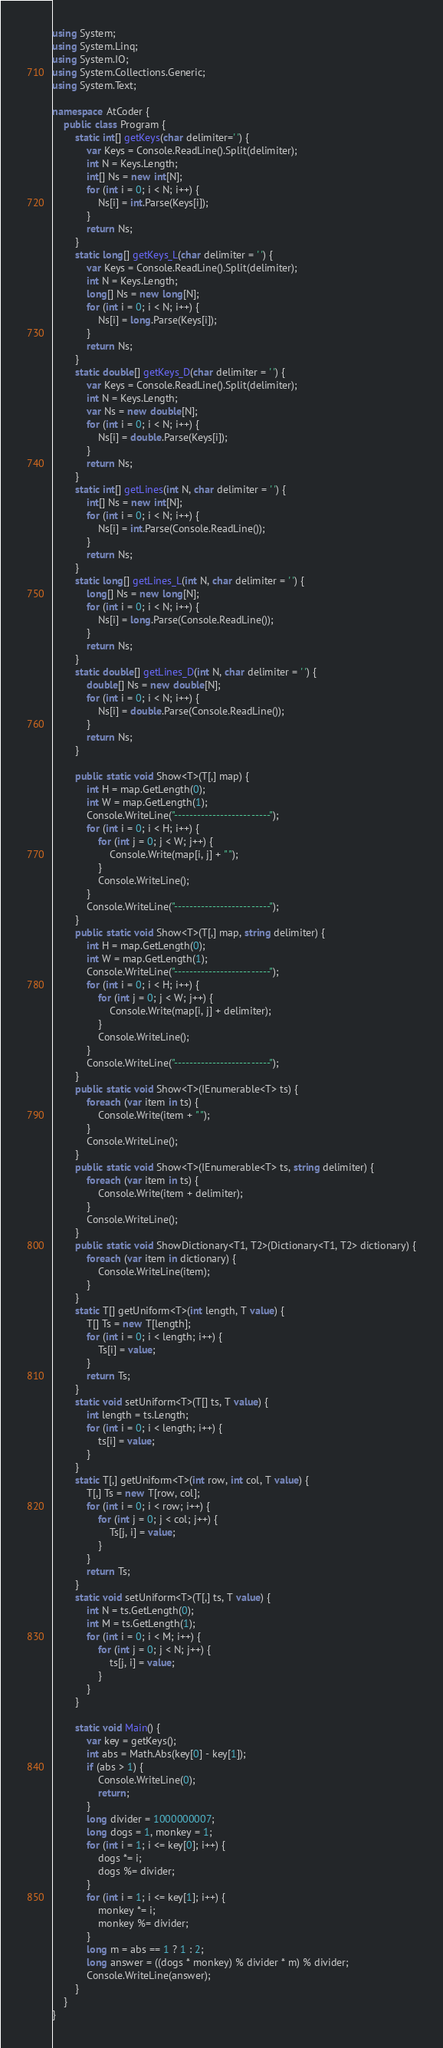<code> <loc_0><loc_0><loc_500><loc_500><_C#_>using System;
using System.Linq;
using System.IO;
using System.Collections.Generic;
using System.Text;

namespace AtCoder {
    public class Program {
        static int[] getKeys(char delimiter=' ') {
            var Keys = Console.ReadLine().Split(delimiter);
            int N = Keys.Length;
            int[] Ns = new int[N];
            for (int i = 0; i < N; i++) {
                Ns[i] = int.Parse(Keys[i]);
            }
            return Ns;
        }
        static long[] getKeys_L(char delimiter = ' ') {
            var Keys = Console.ReadLine().Split(delimiter);
            int N = Keys.Length;
            long[] Ns = new long[N];
            for (int i = 0; i < N; i++) {
                Ns[i] = long.Parse(Keys[i]);
            }
            return Ns;
        }
        static double[] getKeys_D(char delimiter = ' ') {
            var Keys = Console.ReadLine().Split(delimiter);
            int N = Keys.Length;
            var Ns = new double[N];
            for (int i = 0; i < N; i++) {
                Ns[i] = double.Parse(Keys[i]);
            }
            return Ns;
        }
        static int[] getLines(int N, char delimiter = ' ') {
            int[] Ns = new int[N];
            for (int i = 0; i < N; i++) {
                Ns[i] = int.Parse(Console.ReadLine());
            }
            return Ns;
        }
        static long[] getLines_L(int N, char delimiter = ' ') {
            long[] Ns = new long[N];
            for (int i = 0; i < N; i++) {
                Ns[i] = long.Parse(Console.ReadLine());
            }
            return Ns;
        }
        static double[] getLines_D(int N, char delimiter = ' ') {
            double[] Ns = new double[N];
            for (int i = 0; i < N; i++) {
                Ns[i] = double.Parse(Console.ReadLine());
            }
            return Ns;
        }

        public static void Show<T>(T[,] map) {
            int H = map.GetLength(0);
            int W = map.GetLength(1);
            Console.WriteLine("-------------------------");
            for (int i = 0; i < H; i++) {
                for (int j = 0; j < W; j++) {
                    Console.Write(map[i, j] + " ");
                }
                Console.WriteLine();
            }
            Console.WriteLine("-------------------------");
        }
        public static void Show<T>(T[,] map, string delimiter) {
            int H = map.GetLength(0);
            int W = map.GetLength(1);
            Console.WriteLine("-------------------------");
            for (int i = 0; i < H; i++) {
                for (int j = 0; j < W; j++) {
                    Console.Write(map[i, j] + delimiter);
                }
                Console.WriteLine();
            }
            Console.WriteLine("-------------------------");
        }
        public static void Show<T>(IEnumerable<T> ts) {
            foreach (var item in ts) {
                Console.Write(item + " ");
            }
            Console.WriteLine();
        }
        public static void Show<T>(IEnumerable<T> ts, string delimiter) {
            foreach (var item in ts) {
                Console.Write(item + delimiter);
            }
            Console.WriteLine();
        }
        public static void ShowDictionary<T1, T2>(Dictionary<T1, T2> dictionary) {
            foreach (var item in dictionary) {
                Console.WriteLine(item);
            }
        }
        static T[] getUniform<T>(int length, T value) {
            T[] Ts = new T[length];
            for (int i = 0; i < length; i++) {
                Ts[i] = value;
            }
            return Ts;
        }
        static void setUniform<T>(T[] ts, T value) {
            int length = ts.Length;
            for (int i = 0; i < length; i++) {
                ts[i] = value;
            }
        }
        static T[,] getUniform<T>(int row, int col, T value) {
            T[,] Ts = new T[row, col];
            for (int i = 0; i < row; i++) {
                for (int j = 0; j < col; j++) {
                    Ts[j, i] = value;
                }
            }
            return Ts;
        }
        static void setUniform<T>(T[,] ts, T value) {
            int N = ts.GetLength(0);
            int M = ts.GetLength(1);
            for (int i = 0; i < M; i++) {
                for (int j = 0; j < N; j++) {
                    ts[j, i] = value;
                }
            }
        }

        static void Main() {
            var key = getKeys();
            int abs = Math.Abs(key[0] - key[1]);
            if (abs > 1) {
                Console.WriteLine(0);
                return;
            }
            long divider = 1000000007;
            long dogs = 1, monkey = 1;
            for (int i = 1; i <= key[0]; i++) {
                dogs *= i;
                dogs %= divider;
            }
            for (int i = 1; i <= key[1]; i++) {
                monkey *= i;
                monkey %= divider;
            }
            long m = abs == 1 ? 1 : 2;
            long answer = ((dogs * monkey) % divider * m) % divider;
            Console.WriteLine(answer);
        }
    }
}</code> 